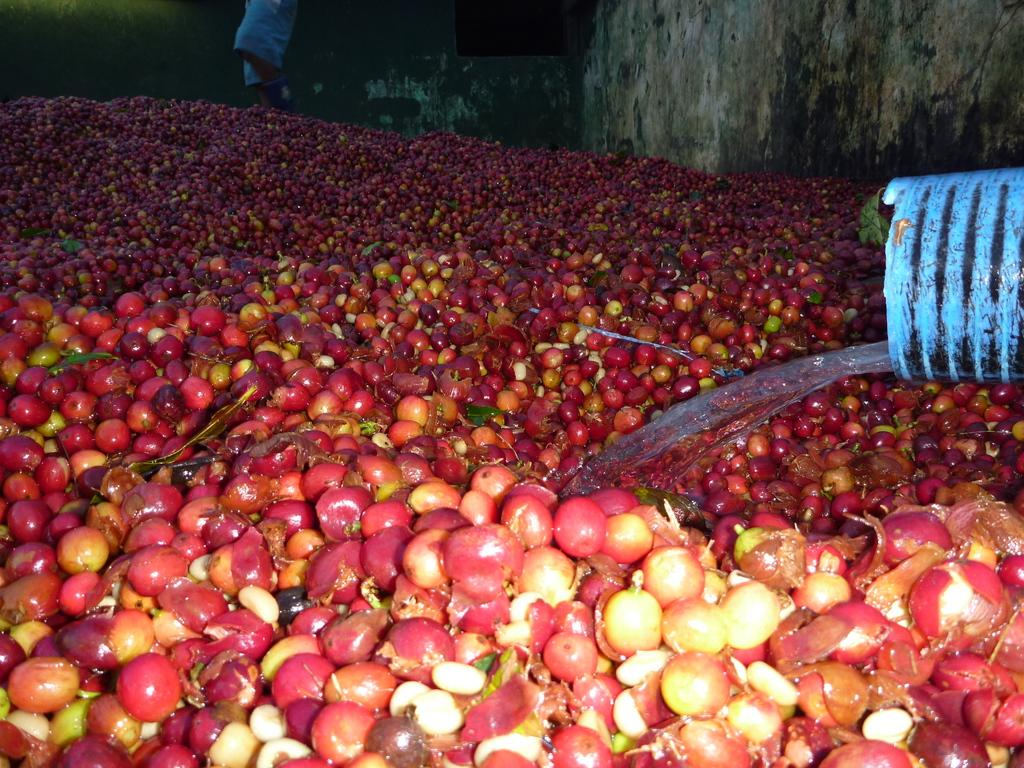What type of food items can be seen in the image? There are fruits in the image. What object is located on the right side of the image? There is a pipe on the right side of the image. What is the liquid substance visible in the image? Water is visible in the image. What can be seen in the background of the image? There is a wall and a person in the background of the image. Can you tell me how many cars are parked near the river in the image? There is no river or cars present in the image. 